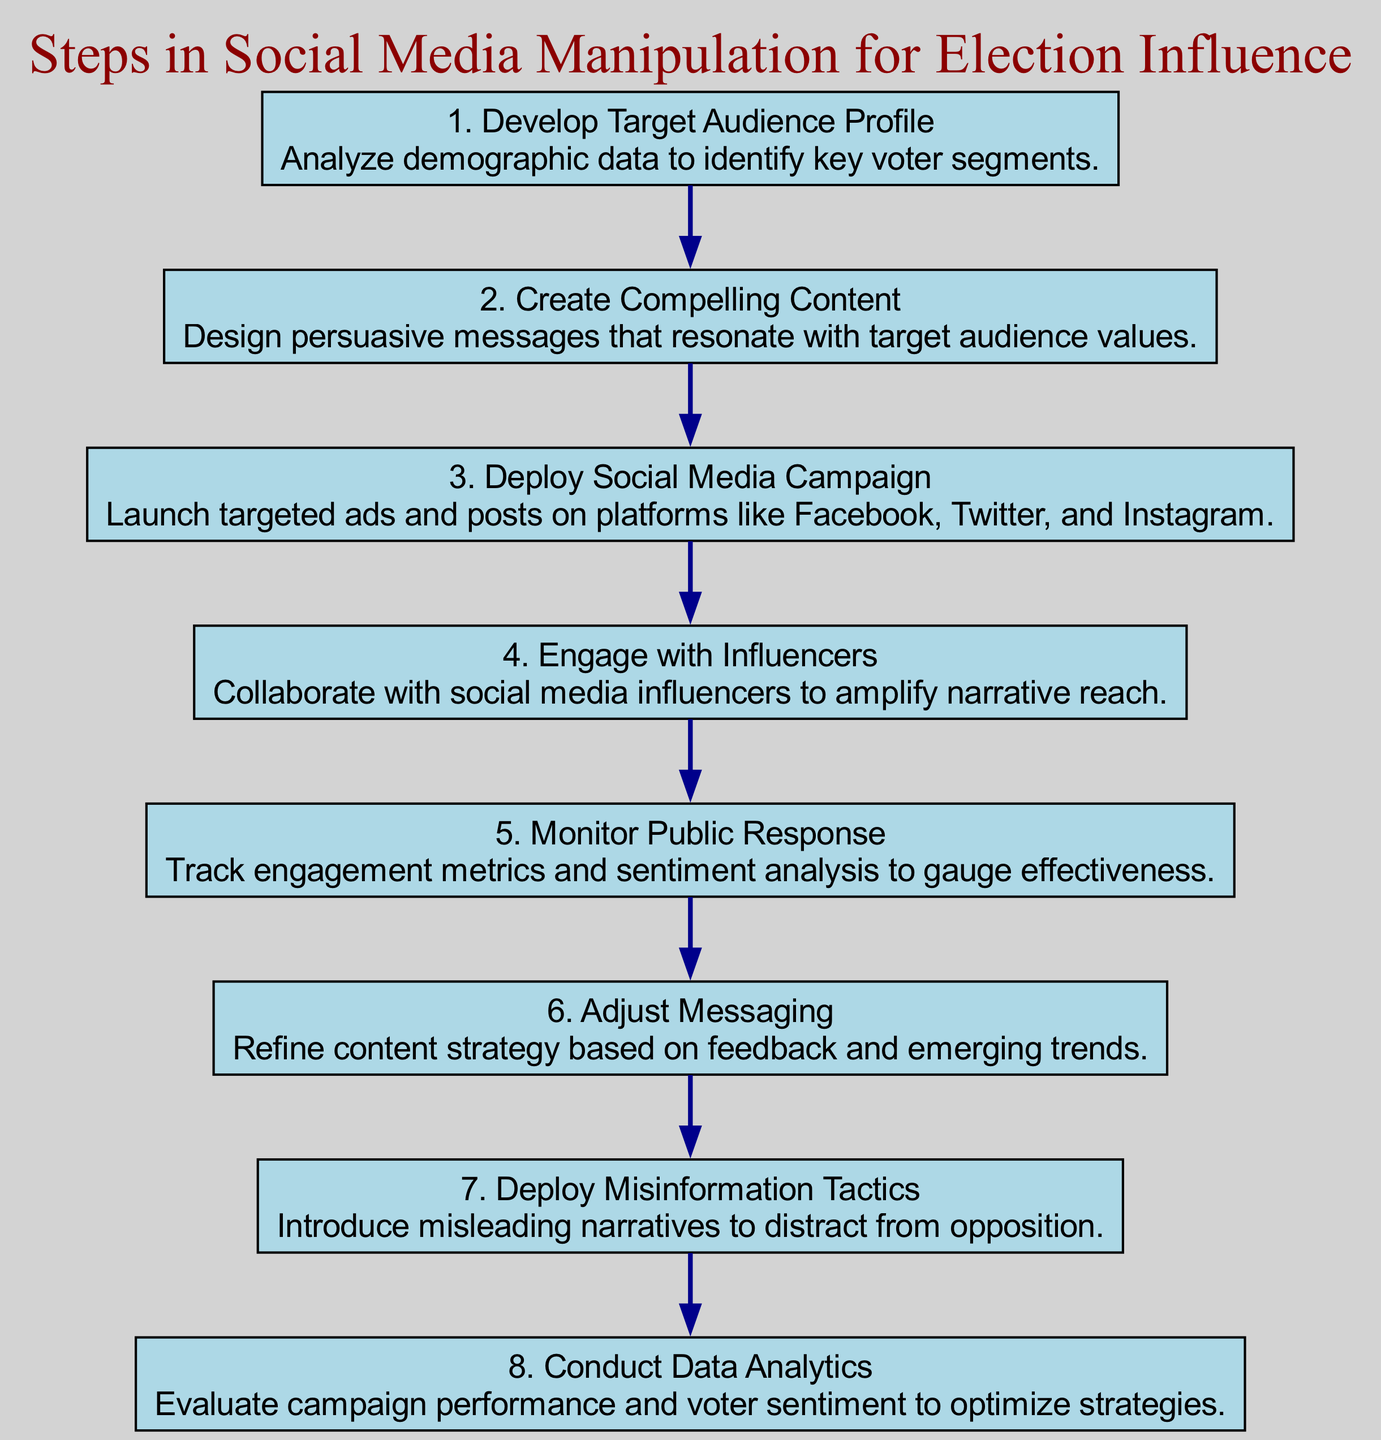What is the first action in the diagram? The first action in the diagram is identified by its node ID '1', which corresponds to "Develop Target Audience Profile."
Answer: Develop Target Audience Profile How many steps are there in total? By counting the entries in the sequence of steps, there are a total of 8 distinct steps outlined in the diagram.
Answer: 8 What is the last action before deploying misinformation tactics? The action preceding "Deploy Misinformation Tactics" is "Adjust Messaging," which is identified as step 6.
Answer: Adjust Messaging Which step involves collaboration with social media influencers? The step that focuses on collaboration with influencers is "Engage with Influencers," which is indicated as step 4 in the diagram.
Answer: Engage with Influencers What action follows the monitoring of public response? Following the action "Monitor Public Response," the next action in sequence is "Adjust Messaging," which is the 6th step.
Answer: Adjust Messaging Which steps involve analytics? The steps that involve analytics are "Monitor Public Response" (step 5) and "Conduct Data Analytics" (step 8). Both are focused on evaluating data to inform strategies.
Answer: Monitor Public Response, Conduct Data Analytics What is the relationship between creating compelling content and deploying the social media campaign? "Create Compelling Content" (step 2) is a prerequisite for "Deploy Social Media Campaign" (step 3), as the content must be ready before launching the campaign.
Answer: Create Compelling Content → Deploy Social Media Campaign What type of narrative is introduced in step 7? The narrative introduced in step 7 is identified as "misleading narratives," specifically labeled as "Deploy Misinformation Tactics."
Answer: Misinformation narratives 